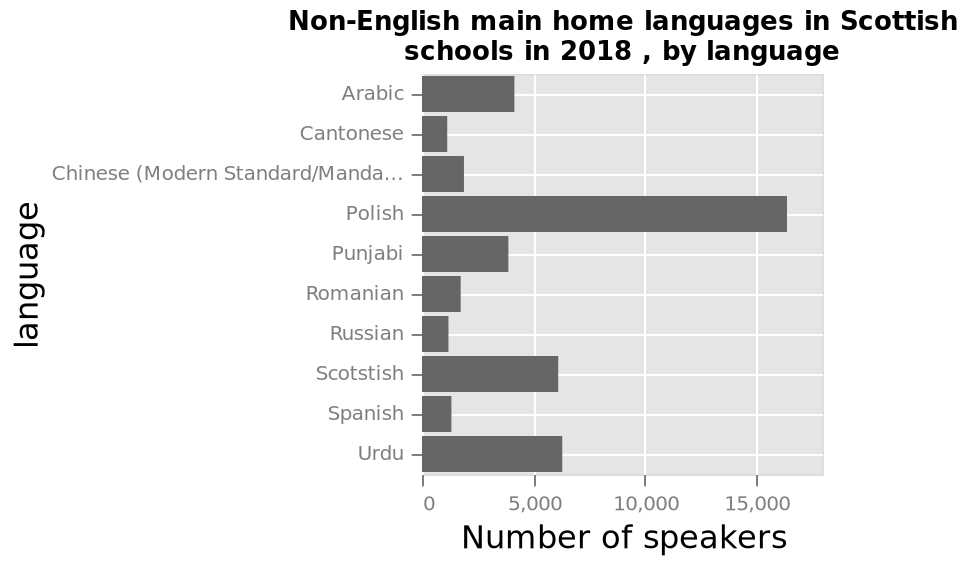<image>
Offer a thorough analysis of the image. In 2018 Scottish schools, Polish is the main non-English language spoken at home with over 15000 speakers. The second and third highest are Urdu and Scotstish with over 5000 speakers each.of the languages listed, russian has the fewest speakers with under 2500 speakers. 